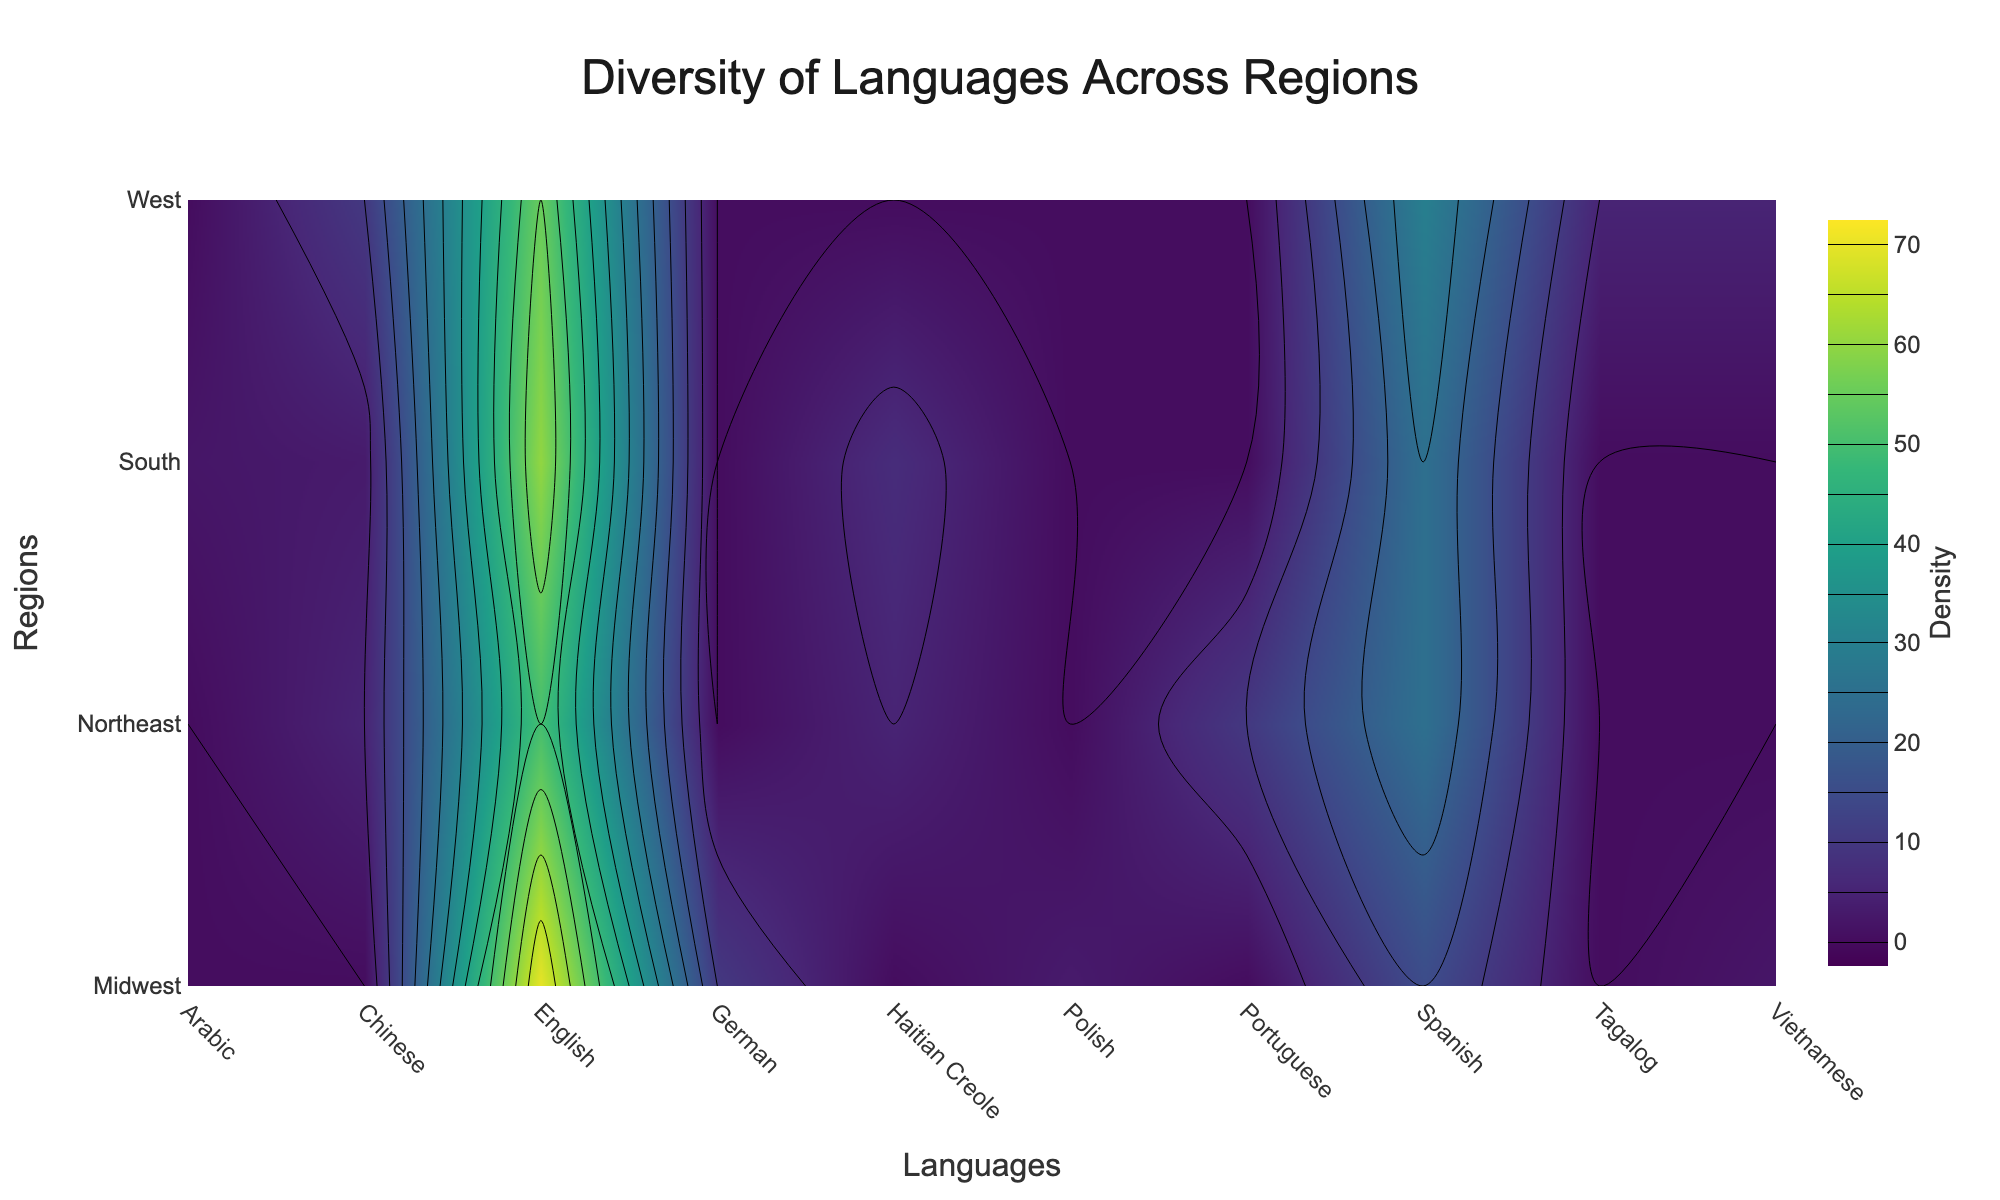what is the main title of the plot? The title of a plot is usually found at the top center of the graphic. In this particular plot, the main title is clearly visible indicating the main subject of the visualization.
Answer: Diversity of Languages Across Regions Which language has the highest density in the Midwest region? To find the language with the highest density in the Midwest, look at the contour plot's y-axis for the Midwest, then move horizontally across that row to find the highest density value. The highest density value in that row corresponds to English.
Answer: English Which regions have Spanish as a commonly spoken language? To identify the regions where Spanish is commonly spoken, scan vertically along the x-axis labeled 'Spanish'. Identify the regions listed on the y-axis with higher contour density values around ‘Spanish’. The regions include Northeast, Midwest, South, and West.
Answer: Northeast, Midwest, South, West What is the sum of density values for Chinese spoken in all regions? To find the sum of density values for Chinese across all regions, locate 'Chinese' on the x-axis and add the corresponding density values visible on the plot. These are 5 for Northeast, 3 for South, and 10 for West. (5 + 3 + 10 = 18)
Answer: 18 Which language has the lowest density distribution in the South region? To determine the language with the lowest density in the South, look along the 'South' entry in the y-axis and find the lowest contour value. The lowest value in the South is Arabic at 2.
Answer: Arabic Compare the density of German spoken in the Midwest to Tagalog in the West. Which is higher? Locate German in the Midwest and Tagalog in the West from the corresponding rows and columns. The density for German in the Midwest is 10, and for Tagalog in the West is 5. Hence, German in the Midwest is higher.
Answer: German in the Midwest Out of the regions listed, which one has the highest diversity in languages spoken? To determine the region with the highest diversity, consider the total number of languages represented and the density values for each language. The Northeast and the West show a wider range of high-density values, particularly the West with significant densities across five languages. Therefore, the West likely has the highest diversity.
Answer: West Is Portuguese spoken in the South region? Look for the South region on the y-axis and move horizontally to see if there is a density value for Portuguese, as indicated by the contour plot. There is no density value indicated for Portuguese in the South.
Answer: No 